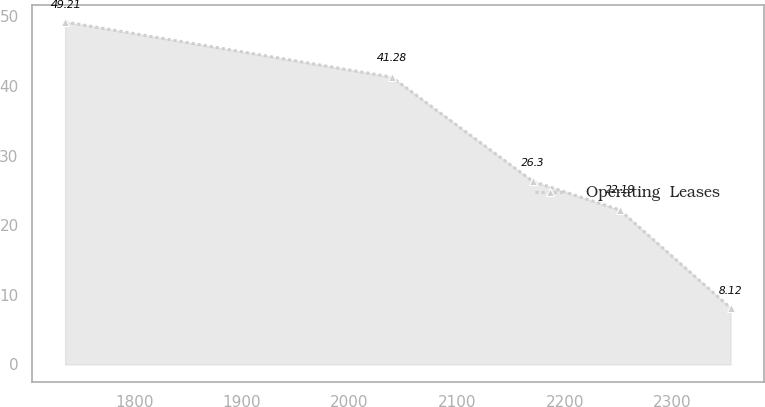Convert chart. <chart><loc_0><loc_0><loc_500><loc_500><line_chart><ecel><fcel>Operating  Leases<nl><fcel>1735.9<fcel>49.21<nl><fcel>2039.32<fcel>41.28<nl><fcel>2170.41<fcel>26.3<nl><fcel>2251.11<fcel>22.19<nl><fcel>2354.01<fcel>8.12<nl></chart> 